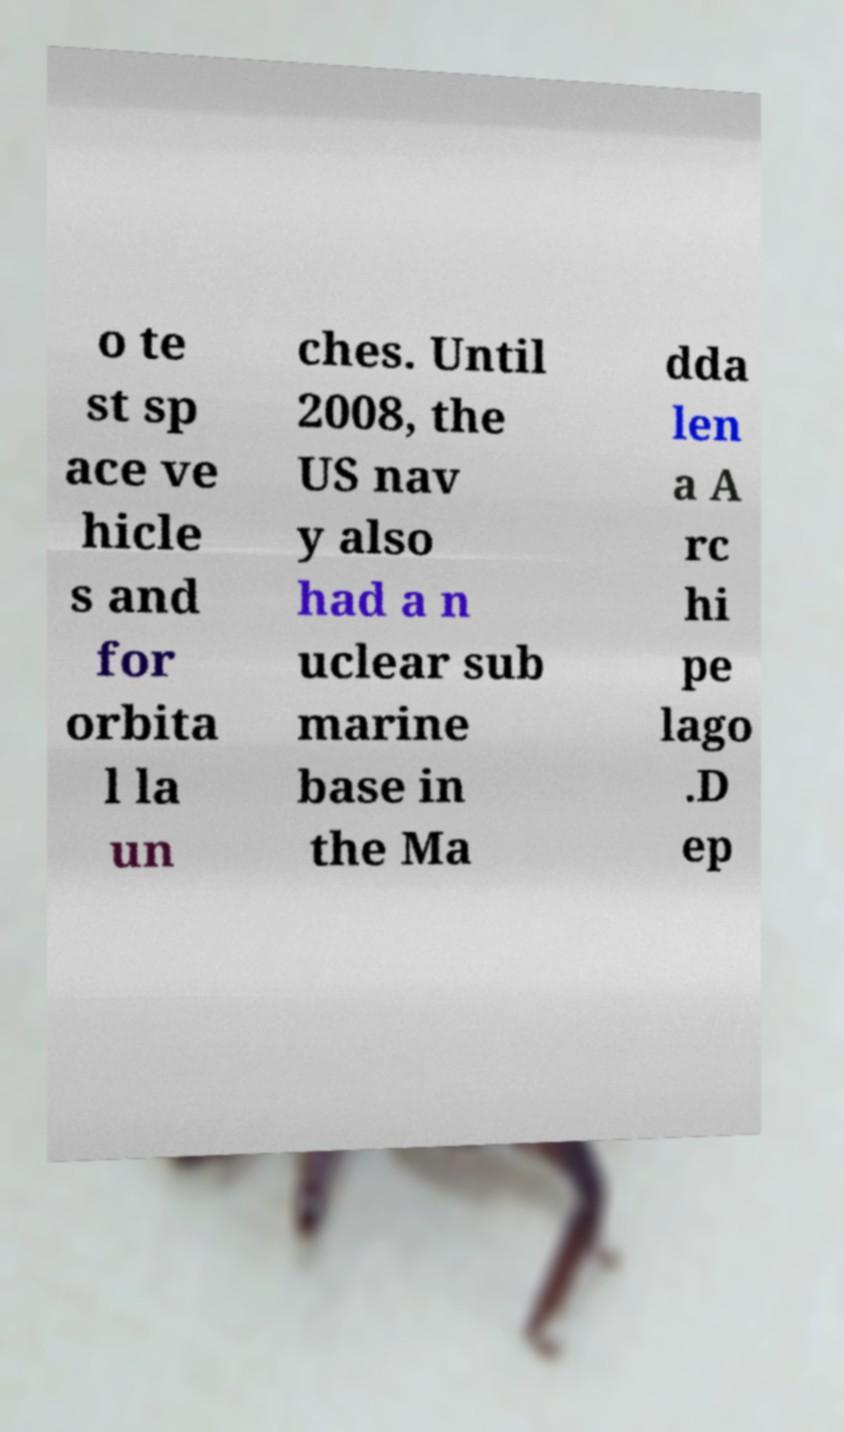Can you accurately transcribe the text from the provided image for me? o te st sp ace ve hicle s and for orbita l la un ches. Until 2008, the US nav y also had a n uclear sub marine base in the Ma dda len a A rc hi pe lago .D ep 